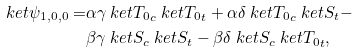<formula> <loc_0><loc_0><loc_500><loc_500>\ k e t { \psi _ { 1 , 0 , 0 } } = & \alpha \gamma \ k e t { T _ { 0 } } _ { c } \ k e t { T _ { 0 } } _ { t } + \alpha \delta \ k e t { T _ { 0 } } _ { c } \ k e t { S } _ { t } - \\ & \beta \gamma \ k e t { S } _ { c } \ k e t { S } _ { t } - \beta \delta \ k e t { S } _ { c } \ k e t { T _ { 0 } } _ { t } ,</formula> 